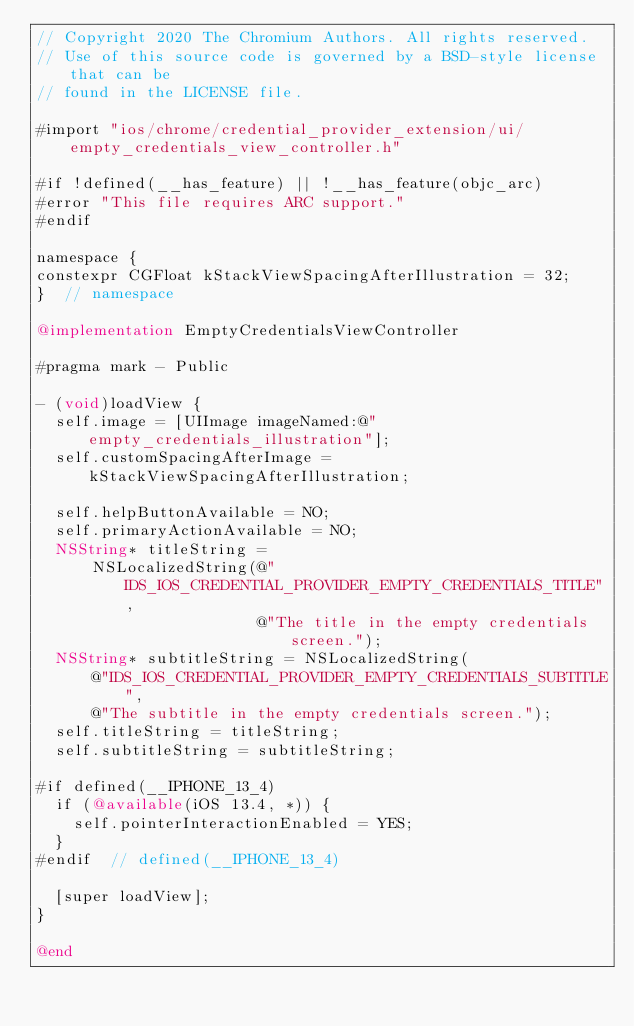Convert code to text. <code><loc_0><loc_0><loc_500><loc_500><_ObjectiveC_>// Copyright 2020 The Chromium Authors. All rights reserved.
// Use of this source code is governed by a BSD-style license that can be
// found in the LICENSE file.

#import "ios/chrome/credential_provider_extension/ui/empty_credentials_view_controller.h"

#if !defined(__has_feature) || !__has_feature(objc_arc)
#error "This file requires ARC support."
#endif

namespace {
constexpr CGFloat kStackViewSpacingAfterIllustration = 32;
}  // namespace

@implementation EmptyCredentialsViewController

#pragma mark - Public

- (void)loadView {
  self.image = [UIImage imageNamed:@"empty_credentials_illustration"];
  self.customSpacingAfterImage = kStackViewSpacingAfterIllustration;

  self.helpButtonAvailable = NO;
  self.primaryActionAvailable = NO;
  NSString* titleString =
      NSLocalizedString(@"IDS_IOS_CREDENTIAL_PROVIDER_EMPTY_CREDENTIALS_TITLE",
                        @"The title in the empty credentials screen.");
  NSString* subtitleString = NSLocalizedString(
      @"IDS_IOS_CREDENTIAL_PROVIDER_EMPTY_CREDENTIALS_SUBTITLE",
      @"The subtitle in the empty credentials screen.");
  self.titleString = titleString;
  self.subtitleString = subtitleString;

#if defined(__IPHONE_13_4)
  if (@available(iOS 13.4, *)) {
    self.pointerInteractionEnabled = YES;
  }
#endif  // defined(__IPHONE_13_4)

  [super loadView];
}

@end
</code> 